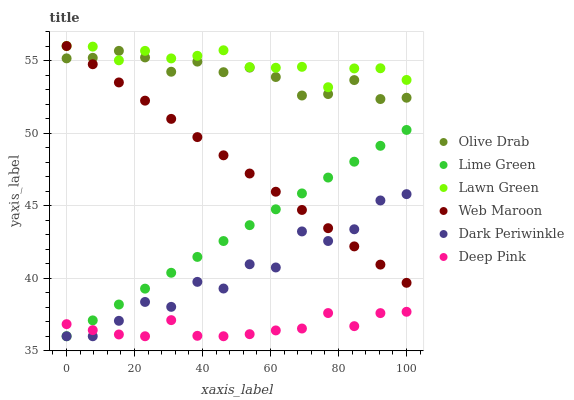Does Deep Pink have the minimum area under the curve?
Answer yes or no. Yes. Does Lawn Green have the maximum area under the curve?
Answer yes or no. Yes. Does Web Maroon have the minimum area under the curve?
Answer yes or no. No. Does Web Maroon have the maximum area under the curve?
Answer yes or no. No. Is Lime Green the smoothest?
Answer yes or no. Yes. Is Dark Periwinkle the roughest?
Answer yes or no. Yes. Is Deep Pink the smoothest?
Answer yes or no. No. Is Deep Pink the roughest?
Answer yes or no. No. Does Deep Pink have the lowest value?
Answer yes or no. Yes. Does Web Maroon have the lowest value?
Answer yes or no. No. Does Web Maroon have the highest value?
Answer yes or no. Yes. Does Deep Pink have the highest value?
Answer yes or no. No. Is Deep Pink less than Web Maroon?
Answer yes or no. Yes. Is Lawn Green greater than Deep Pink?
Answer yes or no. Yes. Does Lawn Green intersect Web Maroon?
Answer yes or no. Yes. Is Lawn Green less than Web Maroon?
Answer yes or no. No. Is Lawn Green greater than Web Maroon?
Answer yes or no. No. Does Deep Pink intersect Web Maroon?
Answer yes or no. No. 